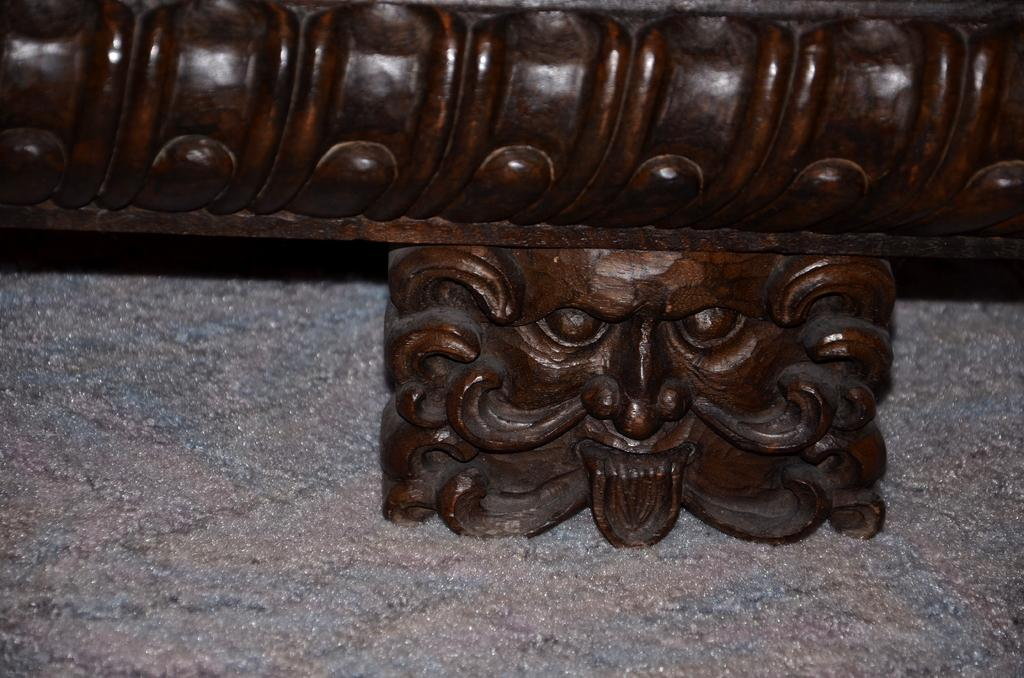What is the main subject of the image? There is a sculpture in the image. What material is the sculpture resting on? The sculpture is on wood. What type of cream can be seen coming out of the mouth of the sculpture? There is no cream or mouth present on the sculpture in the image. 